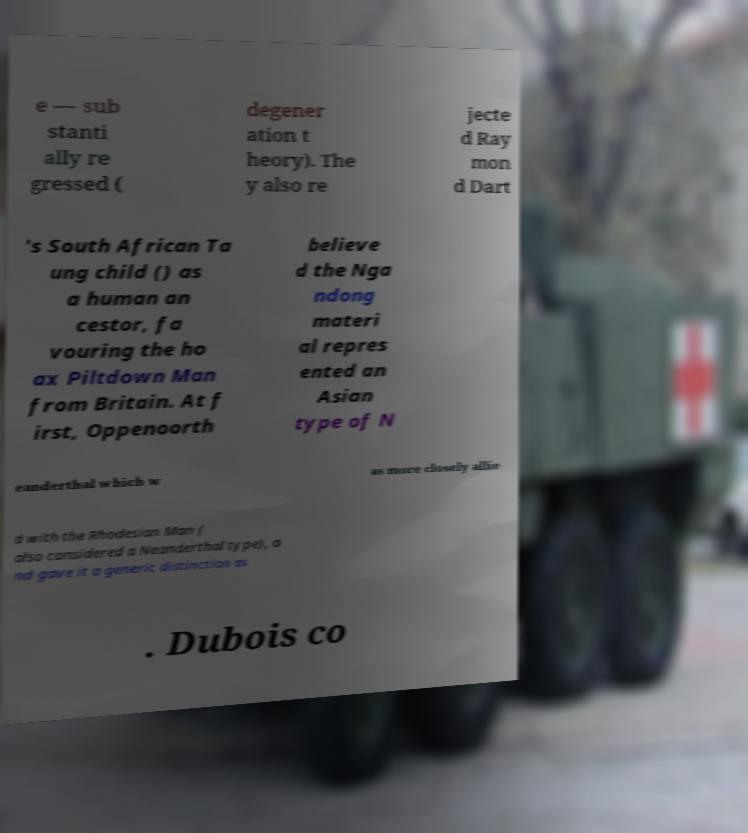What messages or text are displayed in this image? I need them in a readable, typed format. e — sub stanti ally re gressed ( degener ation t heory). The y also re jecte d Ray mon d Dart 's South African Ta ung child () as a human an cestor, fa vouring the ho ax Piltdown Man from Britain. At f irst, Oppenoorth believe d the Nga ndong materi al repres ented an Asian type of N eanderthal which w as more closely allie d with the Rhodesian Man ( also considered a Neanderthal type), a nd gave it a generic distinction as . Dubois co 